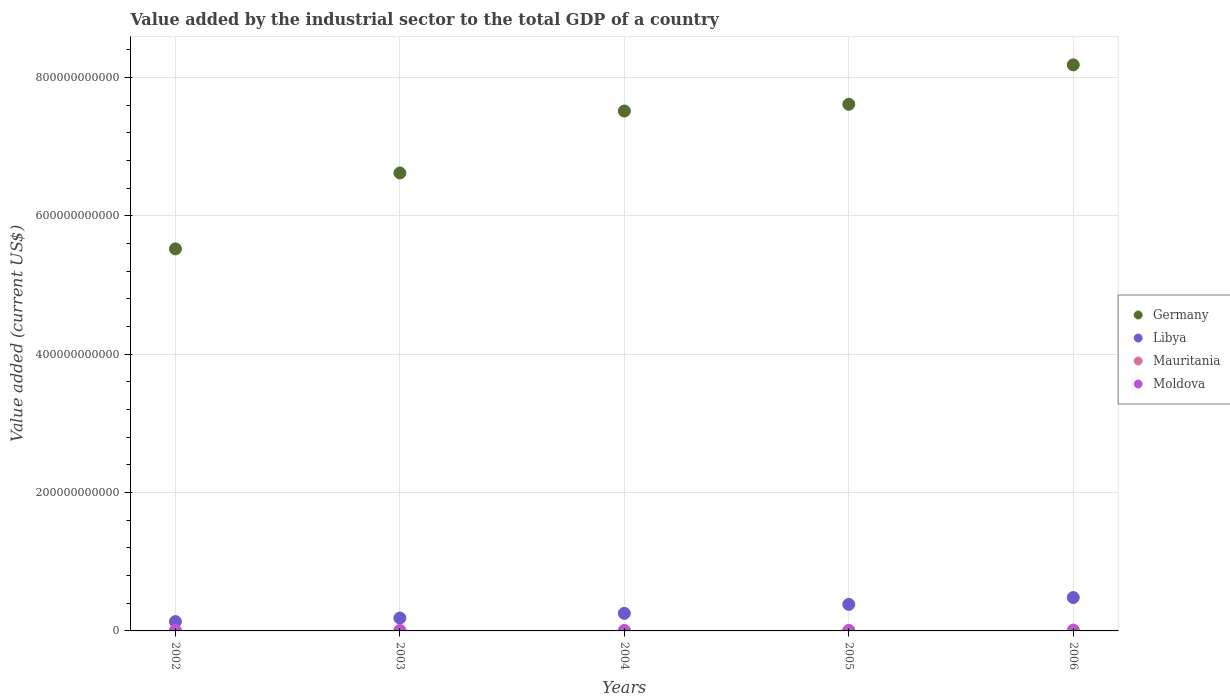How many different coloured dotlines are there?
Ensure brevity in your answer.  4. Is the number of dotlines equal to the number of legend labels?
Make the answer very short. Yes. What is the value added by the industrial sector to the total GDP in Germany in 2002?
Provide a short and direct response. 5.52e+11. Across all years, what is the maximum value added by the industrial sector to the total GDP in Mauritania?
Offer a terse response. 1.32e+09. Across all years, what is the minimum value added by the industrial sector to the total GDP in Germany?
Your answer should be very brief. 5.52e+11. What is the total value added by the industrial sector to the total GDP in Mauritania in the graph?
Offer a very short reply. 3.13e+09. What is the difference between the value added by the industrial sector to the total GDP in Libya in 2005 and that in 2006?
Offer a very short reply. -9.93e+09. What is the difference between the value added by the industrial sector to the total GDP in Moldova in 2004 and the value added by the industrial sector to the total GDP in Libya in 2002?
Ensure brevity in your answer.  -1.31e+1. What is the average value added by the industrial sector to the total GDP in Mauritania per year?
Provide a succinct answer. 6.25e+08. In the year 2002, what is the difference between the value added by the industrial sector to the total GDP in Libya and value added by the industrial sector to the total GDP in Mauritania?
Give a very brief answer. 1.32e+1. What is the ratio of the value added by the industrial sector to the total GDP in Libya in 2004 to that in 2005?
Provide a short and direct response. 0.66. Is the value added by the industrial sector to the total GDP in Libya in 2003 less than that in 2006?
Provide a succinct answer. Yes. Is the difference between the value added by the industrial sector to the total GDP in Libya in 2002 and 2004 greater than the difference between the value added by the industrial sector to the total GDP in Mauritania in 2002 and 2004?
Offer a terse response. No. What is the difference between the highest and the second highest value added by the industrial sector to the total GDP in Moldova?
Offer a terse response. 2.97e+07. What is the difference between the highest and the lowest value added by the industrial sector to the total GDP in Moldova?
Offer a very short reply. 1.07e+08. Is it the case that in every year, the sum of the value added by the industrial sector to the total GDP in Mauritania and value added by the industrial sector to the total GDP in Germany  is greater than the sum of value added by the industrial sector to the total GDP in Libya and value added by the industrial sector to the total GDP in Moldova?
Give a very brief answer. Yes. Is it the case that in every year, the sum of the value added by the industrial sector to the total GDP in Moldova and value added by the industrial sector to the total GDP in Mauritania  is greater than the value added by the industrial sector to the total GDP in Germany?
Make the answer very short. No. Does the value added by the industrial sector to the total GDP in Libya monotonically increase over the years?
Ensure brevity in your answer.  Yes. Is the value added by the industrial sector to the total GDP in Libya strictly greater than the value added by the industrial sector to the total GDP in Germany over the years?
Make the answer very short. No. Is the value added by the industrial sector to the total GDP in Moldova strictly less than the value added by the industrial sector to the total GDP in Germany over the years?
Give a very brief answer. Yes. How many dotlines are there?
Ensure brevity in your answer.  4. What is the difference between two consecutive major ticks on the Y-axis?
Your answer should be compact. 2.00e+11. Are the values on the major ticks of Y-axis written in scientific E-notation?
Your answer should be compact. No. Does the graph contain any zero values?
Your answer should be compact. No. Does the graph contain grids?
Keep it short and to the point. Yes. How many legend labels are there?
Offer a very short reply. 4. How are the legend labels stacked?
Make the answer very short. Vertical. What is the title of the graph?
Your answer should be very brief. Value added by the industrial sector to the total GDP of a country. What is the label or title of the Y-axis?
Ensure brevity in your answer.  Value added (current US$). What is the Value added (current US$) in Germany in 2002?
Provide a short and direct response. 5.52e+11. What is the Value added (current US$) in Libya in 2002?
Ensure brevity in your answer.  1.35e+1. What is the Value added (current US$) of Mauritania in 2002?
Provide a short and direct response. 3.25e+08. What is the Value added (current US$) of Moldova in 2002?
Your response must be concise. 3.36e+08. What is the Value added (current US$) of Germany in 2003?
Provide a short and direct response. 6.62e+11. What is the Value added (current US$) in Libya in 2003?
Make the answer very short. 1.86e+1. What is the Value added (current US$) in Mauritania in 2003?
Give a very brief answer. 3.52e+08. What is the Value added (current US$) in Moldova in 2003?
Provide a succinct answer. 4.14e+08. What is the Value added (current US$) in Germany in 2004?
Your answer should be very brief. 7.51e+11. What is the Value added (current US$) of Libya in 2004?
Offer a terse response. 2.54e+1. What is the Value added (current US$) of Mauritania in 2004?
Your answer should be compact. 4.60e+08. What is the Value added (current US$) in Moldova in 2004?
Make the answer very short. 3.86e+08. What is the Value added (current US$) in Germany in 2005?
Your answer should be very brief. 7.61e+11. What is the Value added (current US$) in Libya in 2005?
Your answer should be compact. 3.83e+1. What is the Value added (current US$) in Mauritania in 2005?
Your answer should be very brief. 6.69e+08. What is the Value added (current US$) in Moldova in 2005?
Your answer should be very brief. 4.10e+08. What is the Value added (current US$) in Germany in 2006?
Give a very brief answer. 8.18e+11. What is the Value added (current US$) in Libya in 2006?
Make the answer very short. 4.83e+1. What is the Value added (current US$) in Mauritania in 2006?
Your response must be concise. 1.32e+09. What is the Value added (current US$) of Moldova in 2006?
Offer a very short reply. 4.43e+08. Across all years, what is the maximum Value added (current US$) in Germany?
Ensure brevity in your answer.  8.18e+11. Across all years, what is the maximum Value added (current US$) of Libya?
Ensure brevity in your answer.  4.83e+1. Across all years, what is the maximum Value added (current US$) in Mauritania?
Your answer should be very brief. 1.32e+09. Across all years, what is the maximum Value added (current US$) of Moldova?
Provide a succinct answer. 4.43e+08. Across all years, what is the minimum Value added (current US$) in Germany?
Provide a succinct answer. 5.52e+11. Across all years, what is the minimum Value added (current US$) in Libya?
Keep it short and to the point. 1.35e+1. Across all years, what is the minimum Value added (current US$) in Mauritania?
Provide a succinct answer. 3.25e+08. Across all years, what is the minimum Value added (current US$) of Moldova?
Provide a short and direct response. 3.36e+08. What is the total Value added (current US$) in Germany in the graph?
Give a very brief answer. 3.55e+12. What is the total Value added (current US$) of Libya in the graph?
Your answer should be compact. 1.44e+11. What is the total Value added (current US$) of Mauritania in the graph?
Give a very brief answer. 3.13e+09. What is the total Value added (current US$) of Moldova in the graph?
Keep it short and to the point. 1.99e+09. What is the difference between the Value added (current US$) of Germany in 2002 and that in 2003?
Your answer should be very brief. -1.10e+11. What is the difference between the Value added (current US$) of Libya in 2002 and that in 2003?
Provide a succinct answer. -5.14e+09. What is the difference between the Value added (current US$) of Mauritania in 2002 and that in 2003?
Ensure brevity in your answer.  -2.76e+07. What is the difference between the Value added (current US$) of Moldova in 2002 and that in 2003?
Ensure brevity in your answer.  -7.74e+07. What is the difference between the Value added (current US$) in Germany in 2002 and that in 2004?
Ensure brevity in your answer.  -1.99e+11. What is the difference between the Value added (current US$) in Libya in 2002 and that in 2004?
Give a very brief answer. -1.19e+1. What is the difference between the Value added (current US$) in Mauritania in 2002 and that in 2004?
Provide a succinct answer. -1.35e+08. What is the difference between the Value added (current US$) in Moldova in 2002 and that in 2004?
Offer a terse response. -4.94e+07. What is the difference between the Value added (current US$) in Germany in 2002 and that in 2005?
Ensure brevity in your answer.  -2.09e+11. What is the difference between the Value added (current US$) in Libya in 2002 and that in 2005?
Provide a succinct answer. -2.48e+1. What is the difference between the Value added (current US$) in Mauritania in 2002 and that in 2005?
Your answer should be very brief. -3.45e+08. What is the difference between the Value added (current US$) in Moldova in 2002 and that in 2005?
Offer a very short reply. -7.35e+07. What is the difference between the Value added (current US$) of Germany in 2002 and that in 2006?
Your answer should be very brief. -2.66e+11. What is the difference between the Value added (current US$) in Libya in 2002 and that in 2006?
Provide a short and direct response. -3.48e+1. What is the difference between the Value added (current US$) in Mauritania in 2002 and that in 2006?
Keep it short and to the point. -9.97e+08. What is the difference between the Value added (current US$) of Moldova in 2002 and that in 2006?
Give a very brief answer. -1.07e+08. What is the difference between the Value added (current US$) of Germany in 2003 and that in 2004?
Provide a succinct answer. -8.95e+1. What is the difference between the Value added (current US$) in Libya in 2003 and that in 2004?
Ensure brevity in your answer.  -6.77e+09. What is the difference between the Value added (current US$) of Mauritania in 2003 and that in 2004?
Your answer should be very brief. -1.08e+08. What is the difference between the Value added (current US$) in Moldova in 2003 and that in 2004?
Provide a succinct answer. 2.80e+07. What is the difference between the Value added (current US$) in Germany in 2003 and that in 2005?
Make the answer very short. -9.93e+1. What is the difference between the Value added (current US$) of Libya in 2003 and that in 2005?
Offer a very short reply. -1.97e+1. What is the difference between the Value added (current US$) of Mauritania in 2003 and that in 2005?
Keep it short and to the point. -3.17e+08. What is the difference between the Value added (current US$) of Moldova in 2003 and that in 2005?
Your answer should be very brief. 3.86e+06. What is the difference between the Value added (current US$) in Germany in 2003 and that in 2006?
Your answer should be compact. -1.56e+11. What is the difference between the Value added (current US$) in Libya in 2003 and that in 2006?
Your answer should be compact. -2.96e+1. What is the difference between the Value added (current US$) of Mauritania in 2003 and that in 2006?
Ensure brevity in your answer.  -9.69e+08. What is the difference between the Value added (current US$) of Moldova in 2003 and that in 2006?
Make the answer very short. -2.97e+07. What is the difference between the Value added (current US$) in Germany in 2004 and that in 2005?
Offer a very short reply. -9.71e+09. What is the difference between the Value added (current US$) in Libya in 2004 and that in 2005?
Your answer should be very brief. -1.29e+1. What is the difference between the Value added (current US$) of Mauritania in 2004 and that in 2005?
Make the answer very short. -2.09e+08. What is the difference between the Value added (current US$) of Moldova in 2004 and that in 2005?
Your answer should be compact. -2.41e+07. What is the difference between the Value added (current US$) in Germany in 2004 and that in 2006?
Offer a terse response. -6.67e+1. What is the difference between the Value added (current US$) of Libya in 2004 and that in 2006?
Provide a succinct answer. -2.29e+1. What is the difference between the Value added (current US$) in Mauritania in 2004 and that in 2006?
Make the answer very short. -8.61e+08. What is the difference between the Value added (current US$) of Moldova in 2004 and that in 2006?
Provide a succinct answer. -5.77e+07. What is the difference between the Value added (current US$) of Germany in 2005 and that in 2006?
Provide a short and direct response. -5.70e+1. What is the difference between the Value added (current US$) in Libya in 2005 and that in 2006?
Your response must be concise. -9.93e+09. What is the difference between the Value added (current US$) of Mauritania in 2005 and that in 2006?
Provide a short and direct response. -6.52e+08. What is the difference between the Value added (current US$) of Moldova in 2005 and that in 2006?
Offer a terse response. -3.36e+07. What is the difference between the Value added (current US$) of Germany in 2002 and the Value added (current US$) of Libya in 2003?
Make the answer very short. 5.34e+11. What is the difference between the Value added (current US$) of Germany in 2002 and the Value added (current US$) of Mauritania in 2003?
Offer a very short reply. 5.52e+11. What is the difference between the Value added (current US$) in Germany in 2002 and the Value added (current US$) in Moldova in 2003?
Make the answer very short. 5.52e+11. What is the difference between the Value added (current US$) in Libya in 2002 and the Value added (current US$) in Mauritania in 2003?
Make the answer very short. 1.31e+1. What is the difference between the Value added (current US$) in Libya in 2002 and the Value added (current US$) in Moldova in 2003?
Keep it short and to the point. 1.31e+1. What is the difference between the Value added (current US$) in Mauritania in 2002 and the Value added (current US$) in Moldova in 2003?
Give a very brief answer. -8.91e+07. What is the difference between the Value added (current US$) in Germany in 2002 and the Value added (current US$) in Libya in 2004?
Your response must be concise. 5.27e+11. What is the difference between the Value added (current US$) of Germany in 2002 and the Value added (current US$) of Mauritania in 2004?
Offer a very short reply. 5.52e+11. What is the difference between the Value added (current US$) of Germany in 2002 and the Value added (current US$) of Moldova in 2004?
Make the answer very short. 5.52e+11. What is the difference between the Value added (current US$) of Libya in 2002 and the Value added (current US$) of Mauritania in 2004?
Keep it short and to the point. 1.30e+1. What is the difference between the Value added (current US$) in Libya in 2002 and the Value added (current US$) in Moldova in 2004?
Give a very brief answer. 1.31e+1. What is the difference between the Value added (current US$) in Mauritania in 2002 and the Value added (current US$) in Moldova in 2004?
Ensure brevity in your answer.  -6.12e+07. What is the difference between the Value added (current US$) in Germany in 2002 and the Value added (current US$) in Libya in 2005?
Your answer should be compact. 5.14e+11. What is the difference between the Value added (current US$) of Germany in 2002 and the Value added (current US$) of Mauritania in 2005?
Provide a succinct answer. 5.52e+11. What is the difference between the Value added (current US$) in Germany in 2002 and the Value added (current US$) in Moldova in 2005?
Offer a terse response. 5.52e+11. What is the difference between the Value added (current US$) of Libya in 2002 and the Value added (current US$) of Mauritania in 2005?
Make the answer very short. 1.28e+1. What is the difference between the Value added (current US$) of Libya in 2002 and the Value added (current US$) of Moldova in 2005?
Keep it short and to the point. 1.31e+1. What is the difference between the Value added (current US$) of Mauritania in 2002 and the Value added (current US$) of Moldova in 2005?
Provide a succinct answer. -8.53e+07. What is the difference between the Value added (current US$) of Germany in 2002 and the Value added (current US$) of Libya in 2006?
Provide a short and direct response. 5.04e+11. What is the difference between the Value added (current US$) in Germany in 2002 and the Value added (current US$) in Mauritania in 2006?
Provide a short and direct response. 5.51e+11. What is the difference between the Value added (current US$) of Germany in 2002 and the Value added (current US$) of Moldova in 2006?
Offer a terse response. 5.52e+11. What is the difference between the Value added (current US$) of Libya in 2002 and the Value added (current US$) of Mauritania in 2006?
Offer a very short reply. 1.22e+1. What is the difference between the Value added (current US$) in Libya in 2002 and the Value added (current US$) in Moldova in 2006?
Ensure brevity in your answer.  1.30e+1. What is the difference between the Value added (current US$) of Mauritania in 2002 and the Value added (current US$) of Moldova in 2006?
Ensure brevity in your answer.  -1.19e+08. What is the difference between the Value added (current US$) of Germany in 2003 and the Value added (current US$) of Libya in 2004?
Offer a very short reply. 6.37e+11. What is the difference between the Value added (current US$) of Germany in 2003 and the Value added (current US$) of Mauritania in 2004?
Your answer should be very brief. 6.61e+11. What is the difference between the Value added (current US$) in Germany in 2003 and the Value added (current US$) in Moldova in 2004?
Provide a short and direct response. 6.62e+11. What is the difference between the Value added (current US$) of Libya in 2003 and the Value added (current US$) of Mauritania in 2004?
Keep it short and to the point. 1.82e+1. What is the difference between the Value added (current US$) of Libya in 2003 and the Value added (current US$) of Moldova in 2004?
Provide a succinct answer. 1.82e+1. What is the difference between the Value added (current US$) of Mauritania in 2003 and the Value added (current US$) of Moldova in 2004?
Your answer should be very brief. -3.36e+07. What is the difference between the Value added (current US$) of Germany in 2003 and the Value added (current US$) of Libya in 2005?
Your answer should be compact. 6.24e+11. What is the difference between the Value added (current US$) of Germany in 2003 and the Value added (current US$) of Mauritania in 2005?
Ensure brevity in your answer.  6.61e+11. What is the difference between the Value added (current US$) of Germany in 2003 and the Value added (current US$) of Moldova in 2005?
Provide a succinct answer. 6.62e+11. What is the difference between the Value added (current US$) of Libya in 2003 and the Value added (current US$) of Mauritania in 2005?
Give a very brief answer. 1.80e+1. What is the difference between the Value added (current US$) of Libya in 2003 and the Value added (current US$) of Moldova in 2005?
Keep it short and to the point. 1.82e+1. What is the difference between the Value added (current US$) in Mauritania in 2003 and the Value added (current US$) in Moldova in 2005?
Your answer should be very brief. -5.77e+07. What is the difference between the Value added (current US$) in Germany in 2003 and the Value added (current US$) in Libya in 2006?
Offer a very short reply. 6.14e+11. What is the difference between the Value added (current US$) of Germany in 2003 and the Value added (current US$) of Mauritania in 2006?
Your answer should be very brief. 6.61e+11. What is the difference between the Value added (current US$) in Germany in 2003 and the Value added (current US$) in Moldova in 2006?
Your response must be concise. 6.62e+11. What is the difference between the Value added (current US$) of Libya in 2003 and the Value added (current US$) of Mauritania in 2006?
Your response must be concise. 1.73e+1. What is the difference between the Value added (current US$) of Libya in 2003 and the Value added (current US$) of Moldova in 2006?
Your answer should be compact. 1.82e+1. What is the difference between the Value added (current US$) of Mauritania in 2003 and the Value added (current US$) of Moldova in 2006?
Make the answer very short. -9.13e+07. What is the difference between the Value added (current US$) in Germany in 2004 and the Value added (current US$) in Libya in 2005?
Ensure brevity in your answer.  7.13e+11. What is the difference between the Value added (current US$) of Germany in 2004 and the Value added (current US$) of Mauritania in 2005?
Ensure brevity in your answer.  7.51e+11. What is the difference between the Value added (current US$) in Germany in 2004 and the Value added (current US$) in Moldova in 2005?
Your answer should be very brief. 7.51e+11. What is the difference between the Value added (current US$) of Libya in 2004 and the Value added (current US$) of Mauritania in 2005?
Provide a short and direct response. 2.47e+1. What is the difference between the Value added (current US$) in Libya in 2004 and the Value added (current US$) in Moldova in 2005?
Give a very brief answer. 2.50e+1. What is the difference between the Value added (current US$) in Mauritania in 2004 and the Value added (current US$) in Moldova in 2005?
Provide a short and direct response. 4.99e+07. What is the difference between the Value added (current US$) in Germany in 2004 and the Value added (current US$) in Libya in 2006?
Your answer should be very brief. 7.03e+11. What is the difference between the Value added (current US$) of Germany in 2004 and the Value added (current US$) of Mauritania in 2006?
Keep it short and to the point. 7.50e+11. What is the difference between the Value added (current US$) in Germany in 2004 and the Value added (current US$) in Moldova in 2006?
Your answer should be very brief. 7.51e+11. What is the difference between the Value added (current US$) of Libya in 2004 and the Value added (current US$) of Mauritania in 2006?
Your answer should be very brief. 2.41e+1. What is the difference between the Value added (current US$) of Libya in 2004 and the Value added (current US$) of Moldova in 2006?
Give a very brief answer. 2.49e+1. What is the difference between the Value added (current US$) in Mauritania in 2004 and the Value added (current US$) in Moldova in 2006?
Make the answer very short. 1.64e+07. What is the difference between the Value added (current US$) of Germany in 2005 and the Value added (current US$) of Libya in 2006?
Give a very brief answer. 7.13e+11. What is the difference between the Value added (current US$) in Germany in 2005 and the Value added (current US$) in Mauritania in 2006?
Offer a terse response. 7.60e+11. What is the difference between the Value added (current US$) in Germany in 2005 and the Value added (current US$) in Moldova in 2006?
Your response must be concise. 7.61e+11. What is the difference between the Value added (current US$) of Libya in 2005 and the Value added (current US$) of Mauritania in 2006?
Provide a succinct answer. 3.70e+1. What is the difference between the Value added (current US$) of Libya in 2005 and the Value added (current US$) of Moldova in 2006?
Give a very brief answer. 3.79e+1. What is the difference between the Value added (current US$) of Mauritania in 2005 and the Value added (current US$) of Moldova in 2006?
Ensure brevity in your answer.  2.26e+08. What is the average Value added (current US$) of Germany per year?
Your answer should be very brief. 7.09e+11. What is the average Value added (current US$) of Libya per year?
Offer a terse response. 2.88e+1. What is the average Value added (current US$) in Mauritania per year?
Ensure brevity in your answer.  6.25e+08. What is the average Value added (current US$) of Moldova per year?
Your response must be concise. 3.98e+08. In the year 2002, what is the difference between the Value added (current US$) of Germany and Value added (current US$) of Libya?
Make the answer very short. 5.39e+11. In the year 2002, what is the difference between the Value added (current US$) of Germany and Value added (current US$) of Mauritania?
Make the answer very short. 5.52e+11. In the year 2002, what is the difference between the Value added (current US$) of Germany and Value added (current US$) of Moldova?
Your answer should be compact. 5.52e+11. In the year 2002, what is the difference between the Value added (current US$) in Libya and Value added (current US$) in Mauritania?
Your answer should be compact. 1.32e+1. In the year 2002, what is the difference between the Value added (current US$) of Libya and Value added (current US$) of Moldova?
Ensure brevity in your answer.  1.31e+1. In the year 2002, what is the difference between the Value added (current US$) of Mauritania and Value added (current US$) of Moldova?
Provide a short and direct response. -1.17e+07. In the year 2003, what is the difference between the Value added (current US$) in Germany and Value added (current US$) in Libya?
Give a very brief answer. 6.43e+11. In the year 2003, what is the difference between the Value added (current US$) of Germany and Value added (current US$) of Mauritania?
Make the answer very short. 6.62e+11. In the year 2003, what is the difference between the Value added (current US$) in Germany and Value added (current US$) in Moldova?
Offer a terse response. 6.62e+11. In the year 2003, what is the difference between the Value added (current US$) in Libya and Value added (current US$) in Mauritania?
Your answer should be very brief. 1.83e+1. In the year 2003, what is the difference between the Value added (current US$) of Libya and Value added (current US$) of Moldova?
Provide a succinct answer. 1.82e+1. In the year 2003, what is the difference between the Value added (current US$) in Mauritania and Value added (current US$) in Moldova?
Give a very brief answer. -6.16e+07. In the year 2004, what is the difference between the Value added (current US$) in Germany and Value added (current US$) in Libya?
Your response must be concise. 7.26e+11. In the year 2004, what is the difference between the Value added (current US$) of Germany and Value added (current US$) of Mauritania?
Offer a terse response. 7.51e+11. In the year 2004, what is the difference between the Value added (current US$) in Germany and Value added (current US$) in Moldova?
Your answer should be very brief. 7.51e+11. In the year 2004, what is the difference between the Value added (current US$) of Libya and Value added (current US$) of Mauritania?
Keep it short and to the point. 2.49e+1. In the year 2004, what is the difference between the Value added (current US$) of Libya and Value added (current US$) of Moldova?
Make the answer very short. 2.50e+1. In the year 2004, what is the difference between the Value added (current US$) in Mauritania and Value added (current US$) in Moldova?
Give a very brief answer. 7.40e+07. In the year 2005, what is the difference between the Value added (current US$) of Germany and Value added (current US$) of Libya?
Your answer should be compact. 7.23e+11. In the year 2005, what is the difference between the Value added (current US$) of Germany and Value added (current US$) of Mauritania?
Your answer should be very brief. 7.61e+11. In the year 2005, what is the difference between the Value added (current US$) of Germany and Value added (current US$) of Moldova?
Make the answer very short. 7.61e+11. In the year 2005, what is the difference between the Value added (current US$) of Libya and Value added (current US$) of Mauritania?
Your response must be concise. 3.77e+1. In the year 2005, what is the difference between the Value added (current US$) of Libya and Value added (current US$) of Moldova?
Provide a succinct answer. 3.79e+1. In the year 2005, what is the difference between the Value added (current US$) of Mauritania and Value added (current US$) of Moldova?
Your response must be concise. 2.59e+08. In the year 2006, what is the difference between the Value added (current US$) of Germany and Value added (current US$) of Libya?
Ensure brevity in your answer.  7.70e+11. In the year 2006, what is the difference between the Value added (current US$) in Germany and Value added (current US$) in Mauritania?
Make the answer very short. 8.17e+11. In the year 2006, what is the difference between the Value added (current US$) in Germany and Value added (current US$) in Moldova?
Give a very brief answer. 8.18e+11. In the year 2006, what is the difference between the Value added (current US$) of Libya and Value added (current US$) of Mauritania?
Provide a succinct answer. 4.69e+1. In the year 2006, what is the difference between the Value added (current US$) of Libya and Value added (current US$) of Moldova?
Your answer should be compact. 4.78e+1. In the year 2006, what is the difference between the Value added (current US$) of Mauritania and Value added (current US$) of Moldova?
Provide a succinct answer. 8.78e+08. What is the ratio of the Value added (current US$) of Germany in 2002 to that in 2003?
Your answer should be compact. 0.83. What is the ratio of the Value added (current US$) of Libya in 2002 to that in 2003?
Your answer should be very brief. 0.72. What is the ratio of the Value added (current US$) of Mauritania in 2002 to that in 2003?
Your answer should be very brief. 0.92. What is the ratio of the Value added (current US$) in Moldova in 2002 to that in 2003?
Provide a short and direct response. 0.81. What is the ratio of the Value added (current US$) in Germany in 2002 to that in 2004?
Offer a terse response. 0.73. What is the ratio of the Value added (current US$) in Libya in 2002 to that in 2004?
Your response must be concise. 0.53. What is the ratio of the Value added (current US$) of Mauritania in 2002 to that in 2004?
Offer a terse response. 0.71. What is the ratio of the Value added (current US$) in Moldova in 2002 to that in 2004?
Offer a terse response. 0.87. What is the ratio of the Value added (current US$) of Germany in 2002 to that in 2005?
Make the answer very short. 0.73. What is the ratio of the Value added (current US$) in Libya in 2002 to that in 2005?
Make the answer very short. 0.35. What is the ratio of the Value added (current US$) of Mauritania in 2002 to that in 2005?
Provide a short and direct response. 0.49. What is the ratio of the Value added (current US$) in Moldova in 2002 to that in 2005?
Provide a short and direct response. 0.82. What is the ratio of the Value added (current US$) in Germany in 2002 to that in 2006?
Your answer should be very brief. 0.67. What is the ratio of the Value added (current US$) in Libya in 2002 to that in 2006?
Give a very brief answer. 0.28. What is the ratio of the Value added (current US$) of Mauritania in 2002 to that in 2006?
Ensure brevity in your answer.  0.25. What is the ratio of the Value added (current US$) of Moldova in 2002 to that in 2006?
Offer a terse response. 0.76. What is the ratio of the Value added (current US$) of Germany in 2003 to that in 2004?
Offer a very short reply. 0.88. What is the ratio of the Value added (current US$) in Libya in 2003 to that in 2004?
Ensure brevity in your answer.  0.73. What is the ratio of the Value added (current US$) of Mauritania in 2003 to that in 2004?
Give a very brief answer. 0.77. What is the ratio of the Value added (current US$) in Moldova in 2003 to that in 2004?
Your answer should be very brief. 1.07. What is the ratio of the Value added (current US$) in Germany in 2003 to that in 2005?
Provide a succinct answer. 0.87. What is the ratio of the Value added (current US$) of Libya in 2003 to that in 2005?
Keep it short and to the point. 0.49. What is the ratio of the Value added (current US$) of Mauritania in 2003 to that in 2005?
Keep it short and to the point. 0.53. What is the ratio of the Value added (current US$) of Moldova in 2003 to that in 2005?
Make the answer very short. 1.01. What is the ratio of the Value added (current US$) of Germany in 2003 to that in 2006?
Make the answer very short. 0.81. What is the ratio of the Value added (current US$) of Libya in 2003 to that in 2006?
Your answer should be very brief. 0.39. What is the ratio of the Value added (current US$) in Mauritania in 2003 to that in 2006?
Provide a short and direct response. 0.27. What is the ratio of the Value added (current US$) in Moldova in 2003 to that in 2006?
Offer a terse response. 0.93. What is the ratio of the Value added (current US$) of Germany in 2004 to that in 2005?
Your response must be concise. 0.99. What is the ratio of the Value added (current US$) in Libya in 2004 to that in 2005?
Offer a very short reply. 0.66. What is the ratio of the Value added (current US$) in Mauritania in 2004 to that in 2005?
Provide a short and direct response. 0.69. What is the ratio of the Value added (current US$) in Moldova in 2004 to that in 2005?
Make the answer very short. 0.94. What is the ratio of the Value added (current US$) in Germany in 2004 to that in 2006?
Your response must be concise. 0.92. What is the ratio of the Value added (current US$) in Libya in 2004 to that in 2006?
Offer a very short reply. 0.53. What is the ratio of the Value added (current US$) in Mauritania in 2004 to that in 2006?
Keep it short and to the point. 0.35. What is the ratio of the Value added (current US$) of Moldova in 2004 to that in 2006?
Offer a terse response. 0.87. What is the ratio of the Value added (current US$) of Germany in 2005 to that in 2006?
Provide a short and direct response. 0.93. What is the ratio of the Value added (current US$) of Libya in 2005 to that in 2006?
Provide a succinct answer. 0.79. What is the ratio of the Value added (current US$) in Mauritania in 2005 to that in 2006?
Offer a very short reply. 0.51. What is the ratio of the Value added (current US$) of Moldova in 2005 to that in 2006?
Provide a succinct answer. 0.92. What is the difference between the highest and the second highest Value added (current US$) of Germany?
Your response must be concise. 5.70e+1. What is the difference between the highest and the second highest Value added (current US$) of Libya?
Your answer should be compact. 9.93e+09. What is the difference between the highest and the second highest Value added (current US$) in Mauritania?
Provide a succinct answer. 6.52e+08. What is the difference between the highest and the second highest Value added (current US$) of Moldova?
Ensure brevity in your answer.  2.97e+07. What is the difference between the highest and the lowest Value added (current US$) in Germany?
Offer a very short reply. 2.66e+11. What is the difference between the highest and the lowest Value added (current US$) in Libya?
Offer a terse response. 3.48e+1. What is the difference between the highest and the lowest Value added (current US$) in Mauritania?
Provide a short and direct response. 9.97e+08. What is the difference between the highest and the lowest Value added (current US$) of Moldova?
Your answer should be very brief. 1.07e+08. 